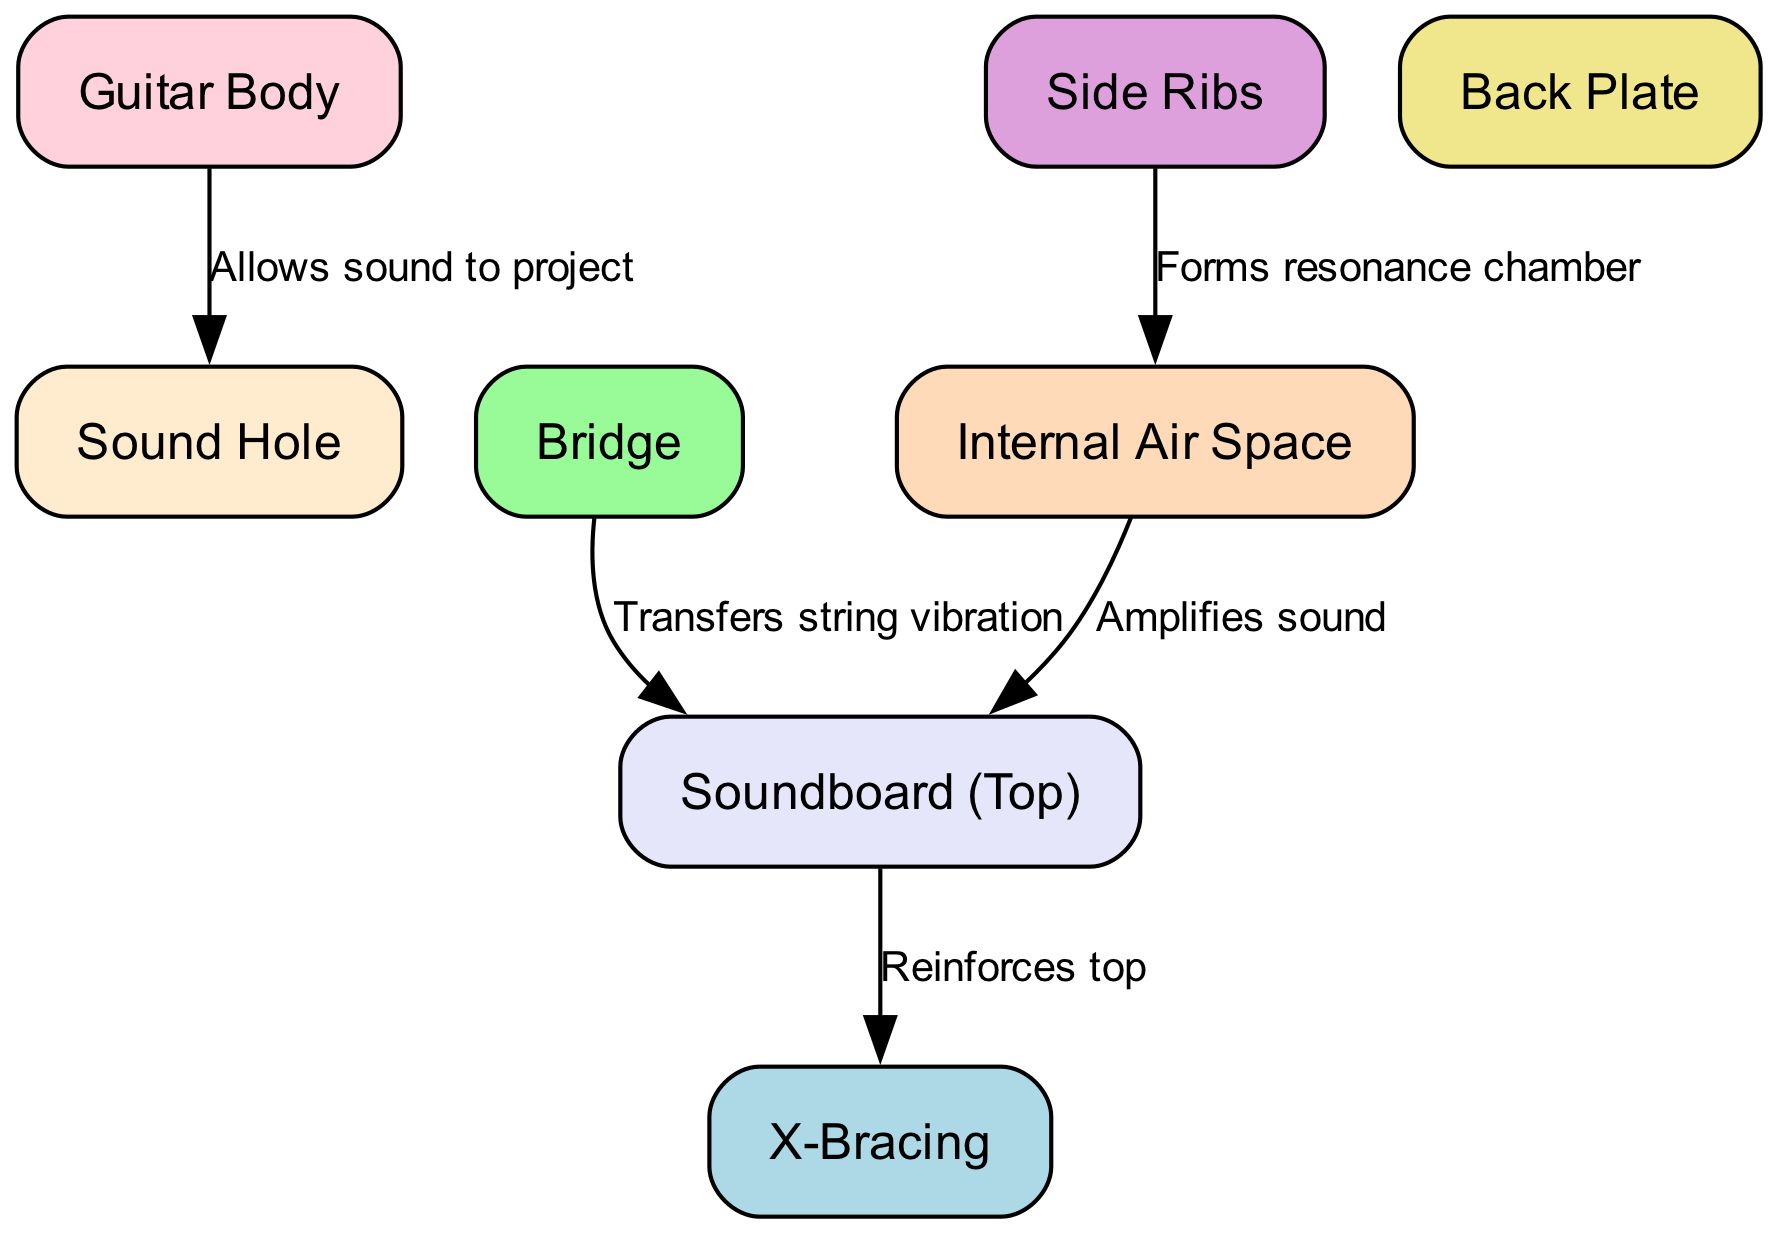What is the main function of the sound hole? The sound hole's function is to allow sound to project from the guitar body. This is evident from the edge labeled "Allows sound to project" connecting the "Guitar Body" node to the "Sound Hole" node.
Answer: Allows sound to project How many nodes are present in the diagram? By counting the number of distinct nodes listed in the diagram, we find there are 8 nodes: Guitar Body, Sound Hole, Soundboard (Top), Bridge, X-Bracing, Back Plate, Side Ribs, and Internal Air Space.
Answer: 8 What role does the bridge serve in the guitar? The bridge's role is to transfer string vibration to the soundboard. This is shown by the edge labeled "Transfers string vibration" linking the "Bridge" node to the "Soundboard (Top)" node.
Answer: Transfers string vibration Which component amplifies sound in the guitar? The component that amplifies sound is the Internal Air Space. The label on the edge linking the "Internal Air Space" node to the "Soundboard (Top)" node states "Amplifies sound," indicating its function.
Answer: Internal Air Space What does the X-Bracing reinforce? The X-Bracing reinforces the soundboard. This relationship is indicated by the edge labeled "Reinforces top," which connects the "Soundboard (Top)" node to the "X-Bracing" node.
Answer: Soundboard How does the internal air space relate to the side ribs? The internal air space is formed by the side ribs, which create a resonance chamber as indicated by the edge connecting the "Side Ribs" node to the "Internal Air Space" node, labeled "Forms resonance chamber."
Answer: Forms resonance chamber Which components are directly involved in sound production? The components directly involved in sound production are the Soundboard, Bridge, and Internal Air Space. The Bridge transfers string vibrations to the Soundboard, and the Internal Air Space amplifies these sounds.
Answer: Soundboard, Bridge, Internal Air Space How does the soundboard connect to sound production? The soundboard plays a crucial role in sound production by receiving vibrations from the bridge and having the internal air space amplify these vibrations. This is evident from the labels on the edges linking these components in the diagram.
Answer: Receives vibrations, amplifies sound 